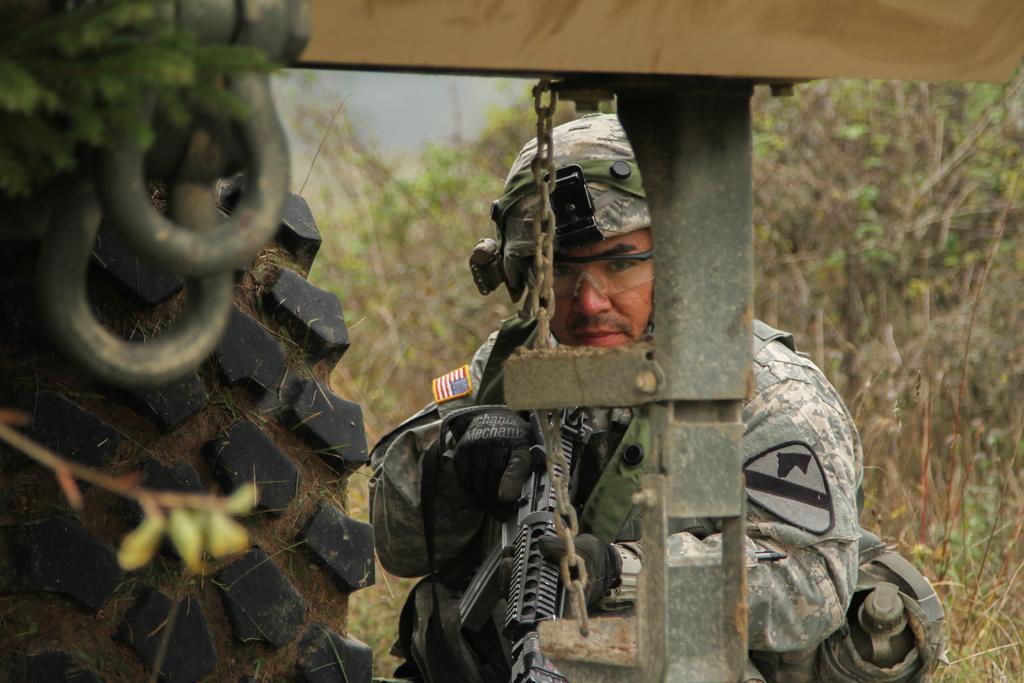In one or two sentences, can you explain what this image depicts? In this image I can see a person carrying bag on his shoulder and holding gun in his hands. In the left side of the image it looks like a tyre and there are some metal objects. In the background there is grass and there are plants. 